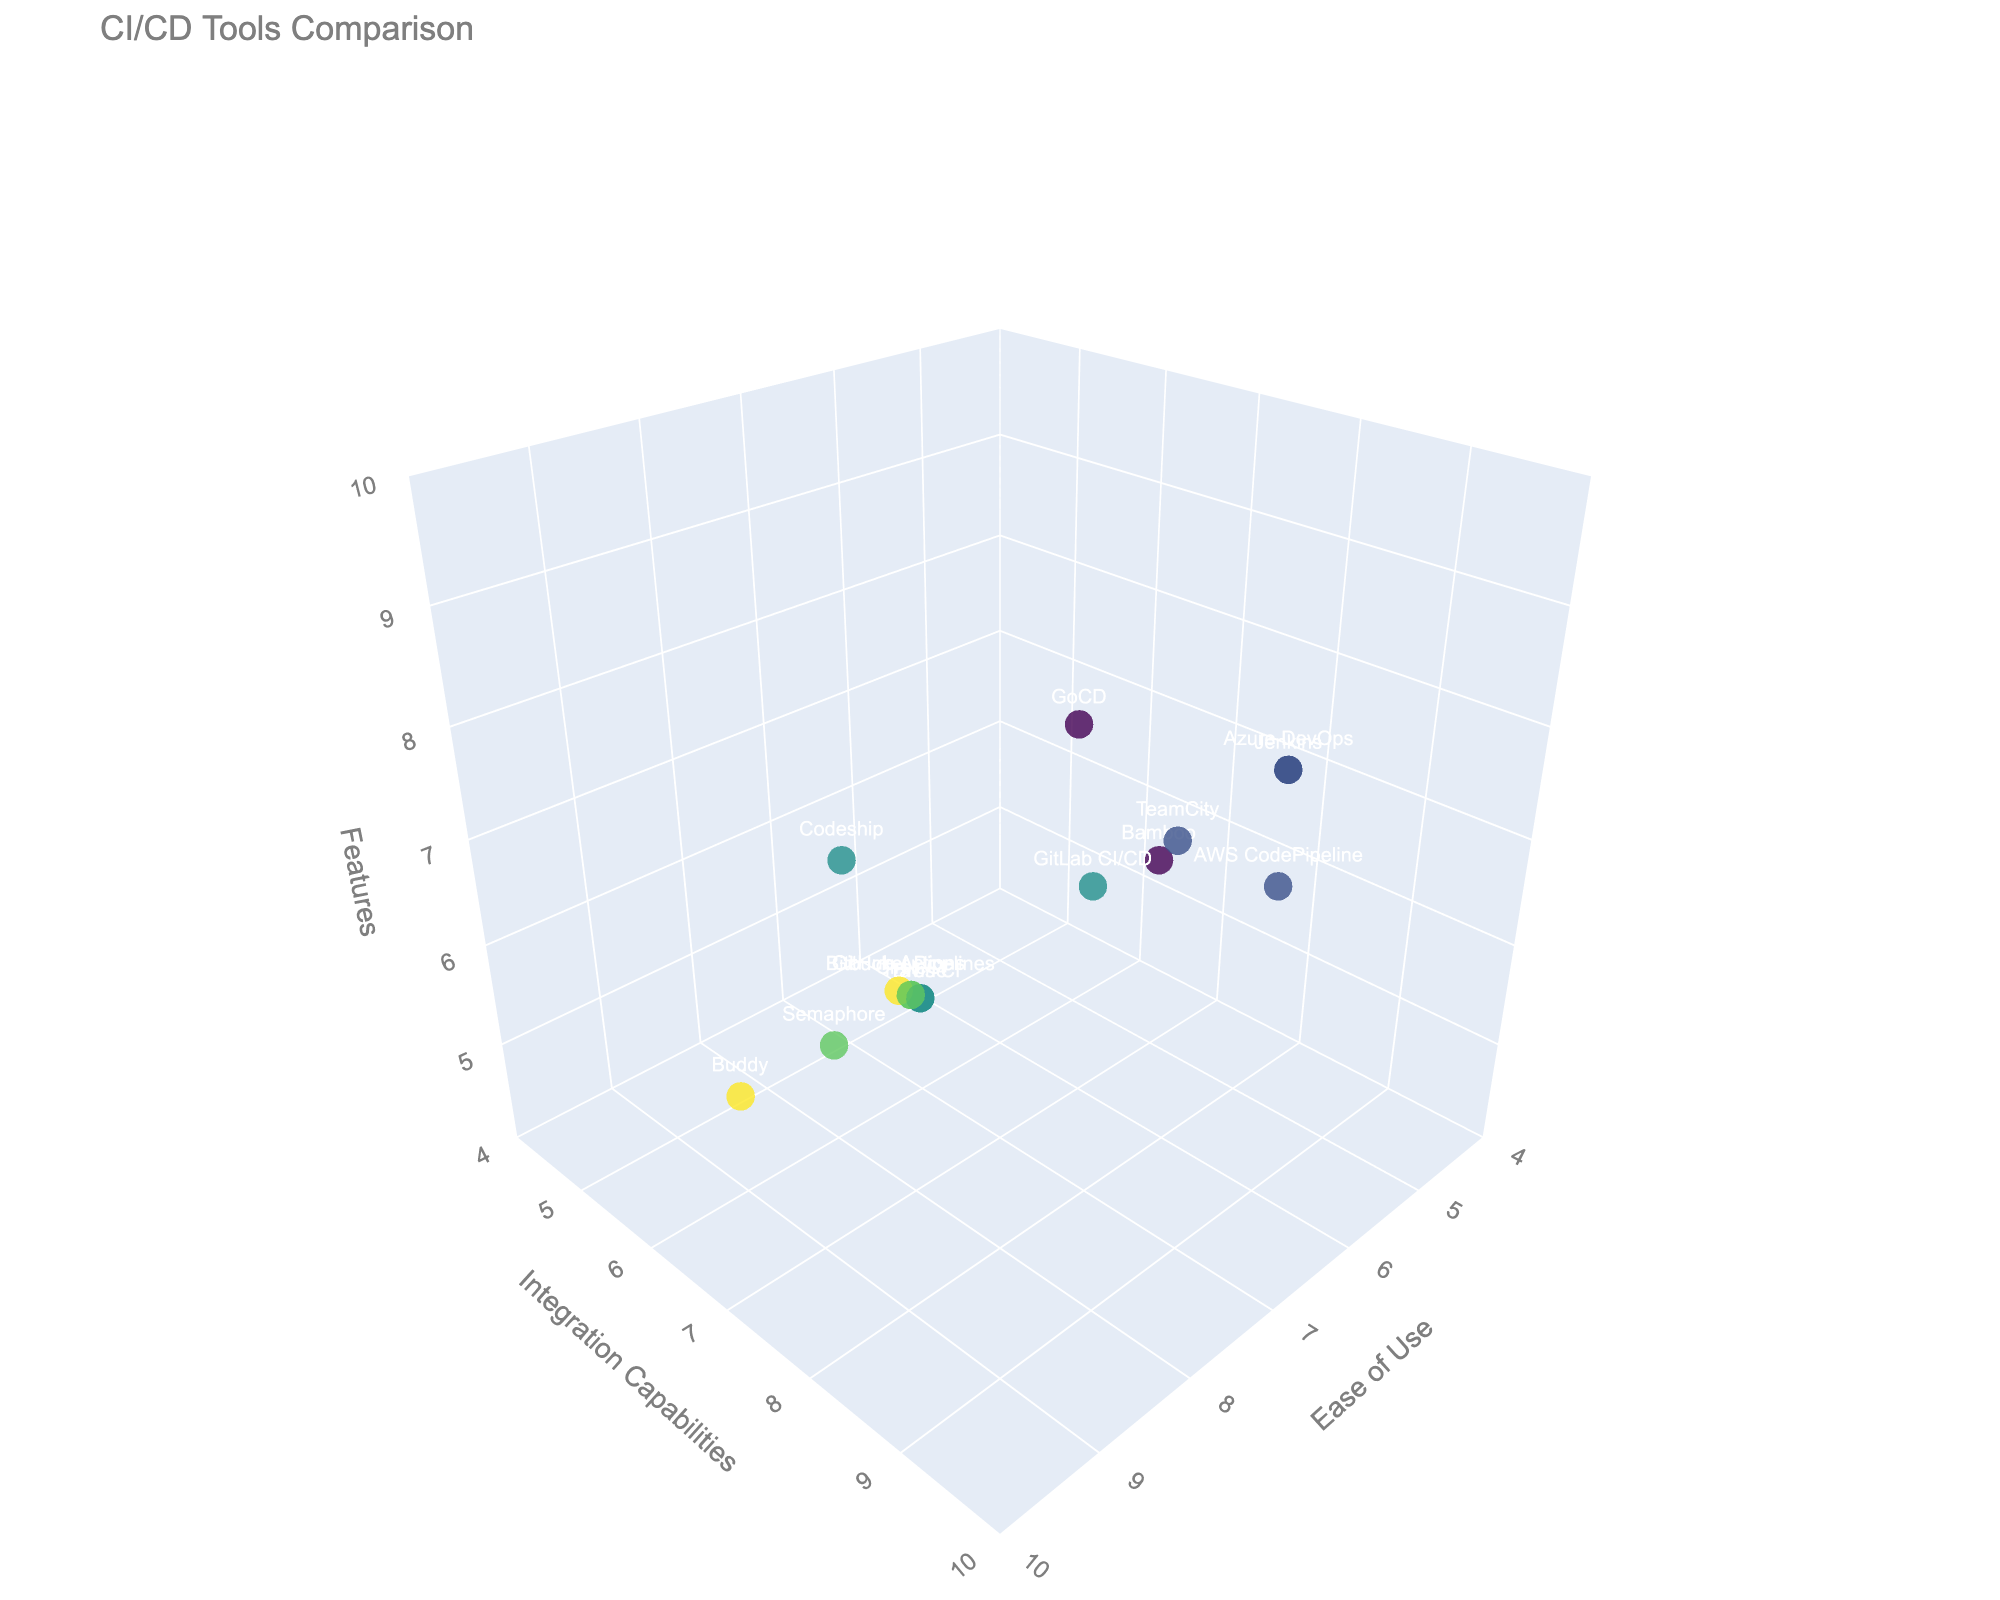What's the title of the plot? The title of the plot is displayed at the top of the figure, usually as a clear, bold text.
Answer: CI/CD Tools Comparison How many tools are evaluated in the plot? Each tool is represented by a distinct data point in the plot, and the labels/text associated with each point indicate the tool's name. By counting the points or tool names, we find there are 15 tools evaluated.
Answer: 15 Which tool has the highest "Ease of Use" rating? To find the tool with the highest "Ease of Use" rating, look at the x-axis values and identify the tool name associated with the maximum value, which is 9.
Answer: GitHub Actions or Buddy What is the range of "Integration Capabilities" values shown in the plot? The y-axis represents "Integration Capabilities". The plot's layout indicates the range by showing the lowest and highest y-axis values, which are 5 to 9.
Answer: 5 to 9 Which two tools have the same ratings for "Ease of Use" and "Features"? By looking at the x-axis (Ease of Use) and z-axis (Features) values and matching them, we find that Jenkins and Azure DevOps both have "Ease of Use" of 6 and "Features" of 8.
Answer: Jenkins and Azure DevOps How do the tools with "Integration Capabilities" of 6 compare in terms of "Ease of Use"? Identify tools with "Integration Capabilities" of 6 (y-axis) and compare their x-axis values. These tools are Travis CI, Drone, Codeship, and Buddy, with respective "Ease of Use" of 7, 7, 7, and 9.
Answer: Travis CI, Drone, Codeship (7), Buddy (9) Which tool(s) exhibit the perfect balance across all three dimensions (Ease of Use, Integration Capabilities, and Features) using approximate central values? Central values can be approximated around midpoints of the axes: "Ease of Use" ~ 7.5, "Integration Capabilities" ~ 7.5, and "Features" ~ 6.5. By checking the tools close to these values, GitHub Actions (9, 8, 7) and TeamCity (6, 8, 7) show a good balance.
Answer: GitHub Actions and TeamCity Is there any tool with the lowest "Ease of Use" rating, but high values for the other two dimensions? Check the tool with the lowest "Ease of Use" rating and then check its values for "Integration Capabilities" and "Features". Bamboo with an "Ease of Use" of 5 has decent "Integration Capabilities" (7) and "Features" (6).
Answer: Bamboo What is the overall trend observed among the tools regarding "Ease of Use" versus "Features"? To observe the trend, look at the dispersion and alignment of the data points along the x-axis (Ease of Use) and z-axis (Features). It shows a positive correlation; tools with higher "Ease of Use" tend to have moderate to high "Features" values, but there are some variances.
Answer: Positive Correlation Which tool has an "Integration Capabilities" rating of 7 and highest "Ease of Use"? Identify tools with "Integration Capabilities" of 7 (y-axis) and check their "Ease of Use" (x-axis). Bitbucket Pipelines with an "Ease of Use" rating of 8 fits this criteria.
Answer: Bitbucket Pipelines 